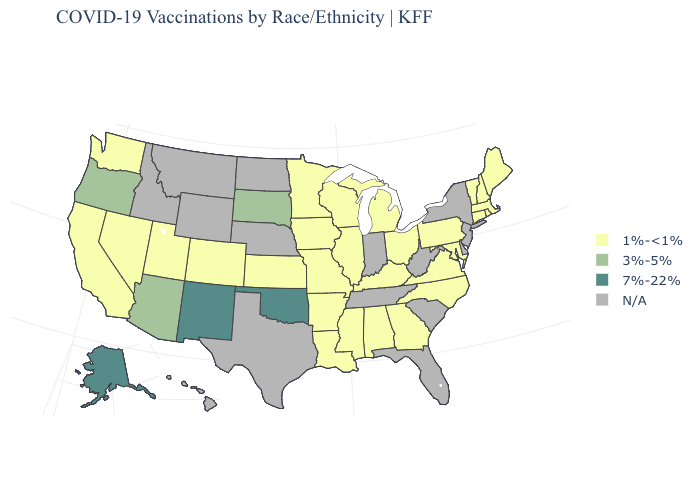What is the value of North Carolina?
Be succinct. 1%-<1%. Name the states that have a value in the range 3%-5%?
Write a very short answer. Arizona, Oregon, South Dakota. Among the states that border Minnesota , does South Dakota have the highest value?
Concise answer only. Yes. Name the states that have a value in the range 3%-5%?
Quick response, please. Arizona, Oregon, South Dakota. What is the value of Louisiana?
Keep it brief. 1%-<1%. Name the states that have a value in the range 7%-22%?
Keep it brief. Alaska, New Mexico, Oklahoma. Among the states that border New Hampshire , which have the highest value?
Concise answer only. Maine, Massachusetts, Vermont. Name the states that have a value in the range 1%-<1%?
Short answer required. Alabama, Arkansas, California, Colorado, Connecticut, Georgia, Illinois, Iowa, Kansas, Kentucky, Louisiana, Maine, Maryland, Massachusetts, Michigan, Minnesota, Mississippi, Missouri, Nevada, New Hampshire, North Carolina, Ohio, Pennsylvania, Rhode Island, Utah, Vermont, Virginia, Washington, Wisconsin. What is the lowest value in the USA?
Short answer required. 1%-<1%. Among the states that border Michigan , which have the lowest value?
Concise answer only. Ohio, Wisconsin. Which states have the lowest value in the Northeast?
Short answer required. Connecticut, Maine, Massachusetts, New Hampshire, Pennsylvania, Rhode Island, Vermont. Does the map have missing data?
Concise answer only. Yes. What is the highest value in the West ?
Write a very short answer. 7%-22%. Is the legend a continuous bar?
Short answer required. No. What is the highest value in states that border Kansas?
Quick response, please. 7%-22%. 